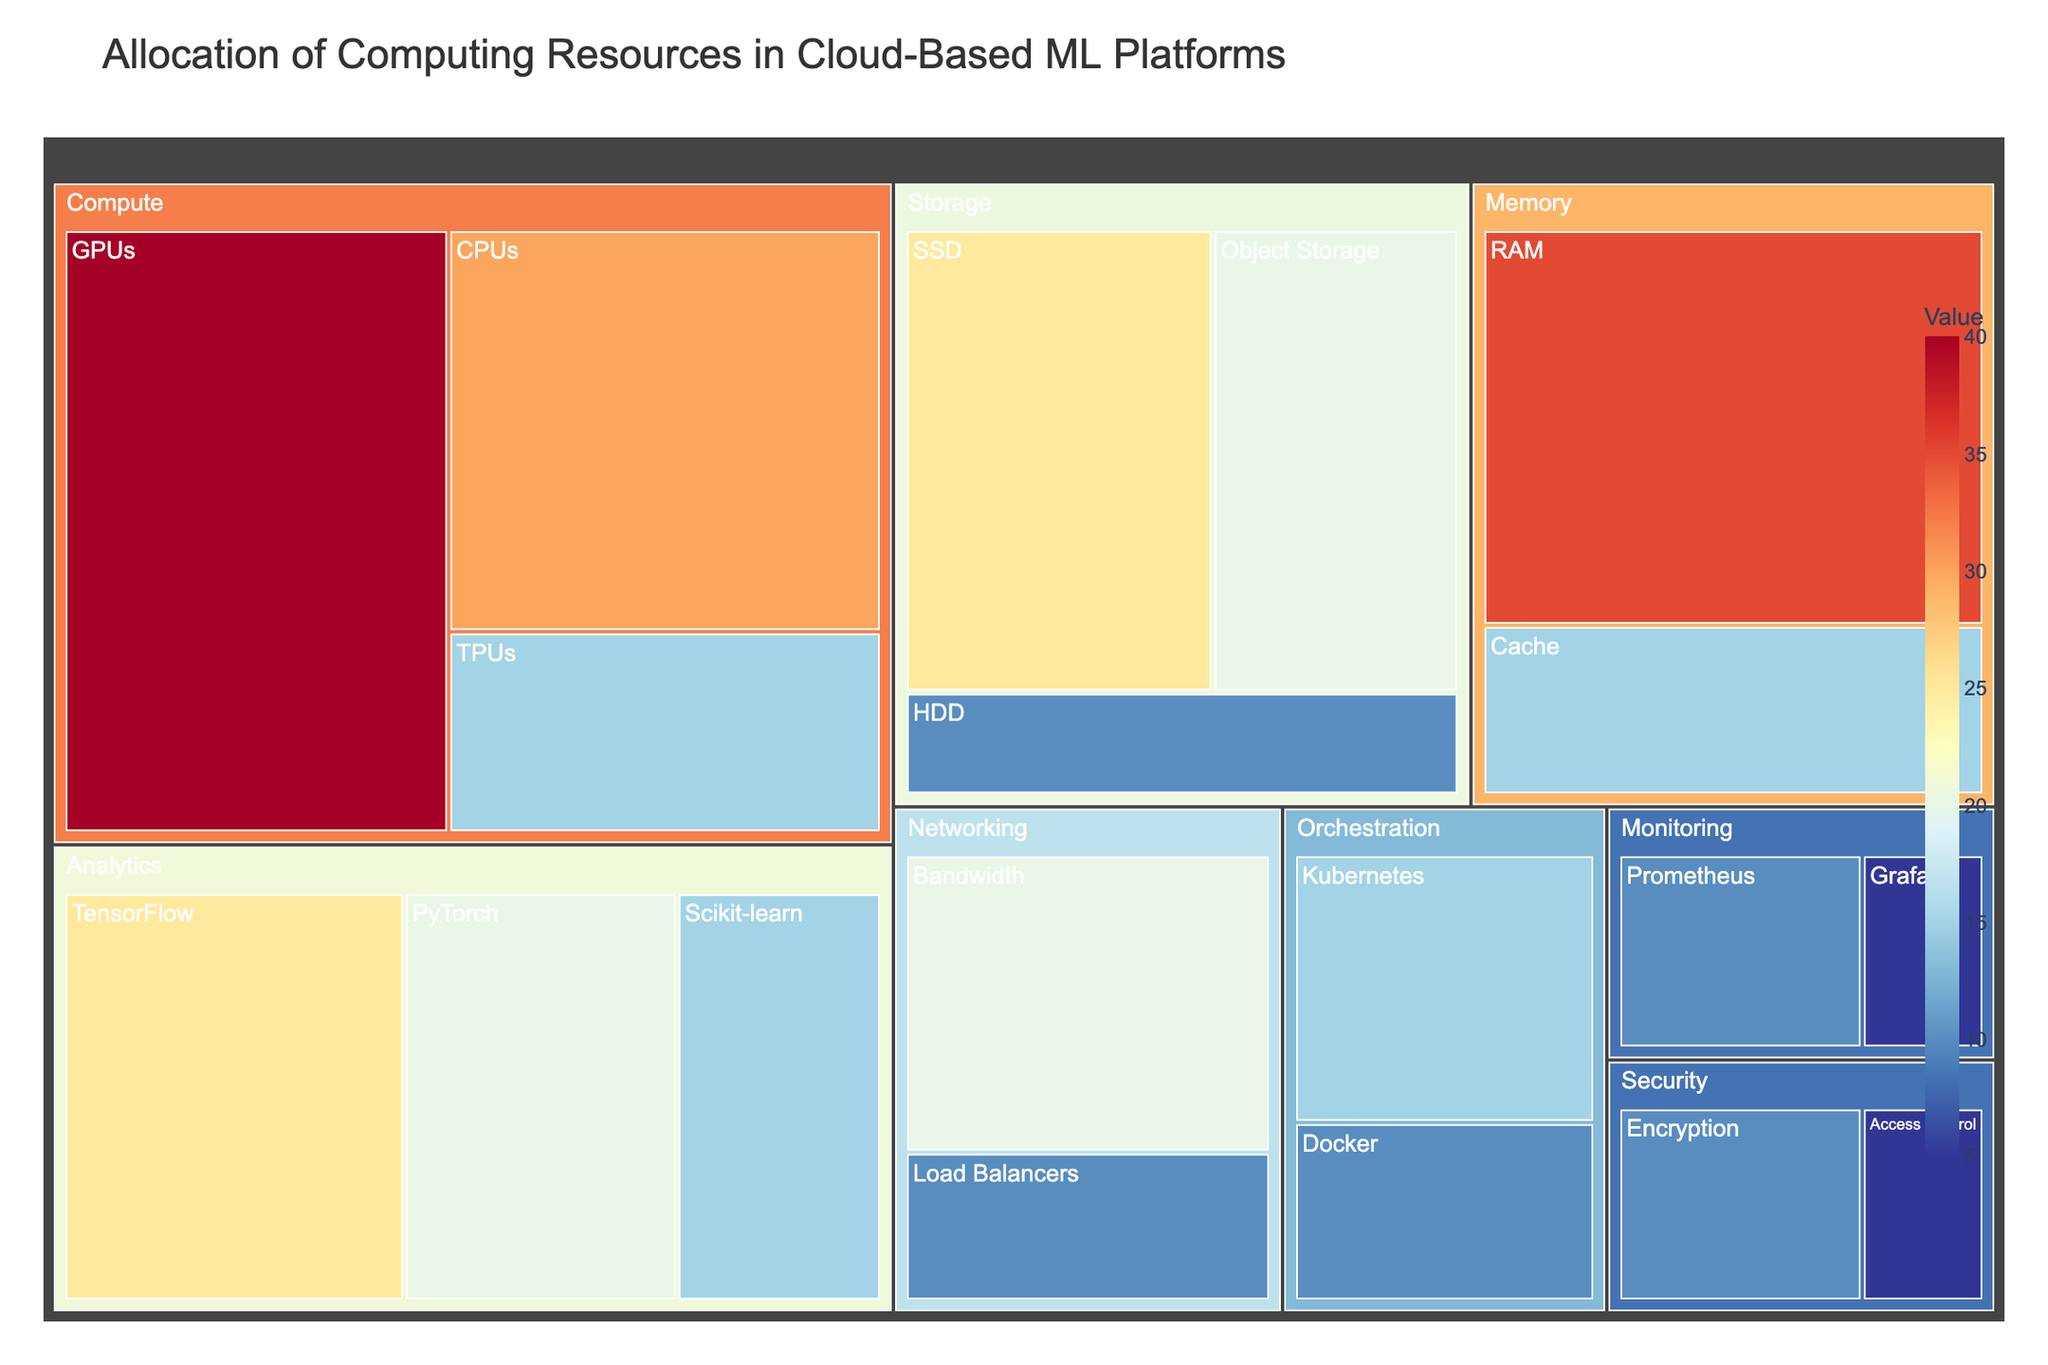Which category has the highest allocation of computing resources? To determine the category with the highest allocation, we sum up the values of the subcategories within each category. The Compute category has a total of 85 (40 GPUs + 30 CPUs + 15 TPUs), which is the highest.
Answer: Compute What are the values associated with the subcategories under Storage? The subcategories under Storage and their respective values are SSD (25), HDD (10), and Object Storage (20).
Answer: SSD: 25, HDD: 10, Object Storage: 20 What's the combined value of the Analytics category? We need to sum up the values of all subcategories under Analytics: TensorFlow (25) + PyTorch (20) + Scikit-learn (15) = 60.
Answer: 60 Which subcategory under Networking has a higher value, Bandwidth or Load Balancers? Comparing the values, Bandwidth has a value of 20, while Load Balancers have a value of 10. 20 is greater than 10, so Bandwidth has a higher value.
Answer: Bandwidth What's the total allocation of resources for the categories with values less than 20? Sum the values of all subcategories with values less than 20: Storage (HDD: 10) + Storage (Object Storage: 20) + Compute (TPUs: 15) + Memory (Cache: 15) + Networking (Load Balancers: 10) + Orchestration (Kubernetes: 15) + Orchestration (Docker: 10) + Monitoring (Prometheus: 10) + Monitoring (Grafana: 5) + Security (Encryption: 10) + Security (Access Control: 5) = 125.
Answer: 125 What is the color scale used in the Treemap? The color scale used in the Treemap is a reversed version of the RdYlBu scale.
Answer: Reversed RdYlBu How many subcategories are there in total? Count all subcategories listed under each main category: Compute (3), Storage (3), Memory (2), Networking (2), Orchestration (2), Analytics (3), Monitoring (2), Security (2). Adding them up, we get 3 + 3 + 2 + 2 + 2 + 3 + 2 + 2 = 19.
Answer: 19 What is the smallest subcategory value and which subcategory does it correspond to? The smallest value among all subcategories is 5, which corresponds to both Grafana and Access Control.
Answer: 5 (Grafana and Access Control) 